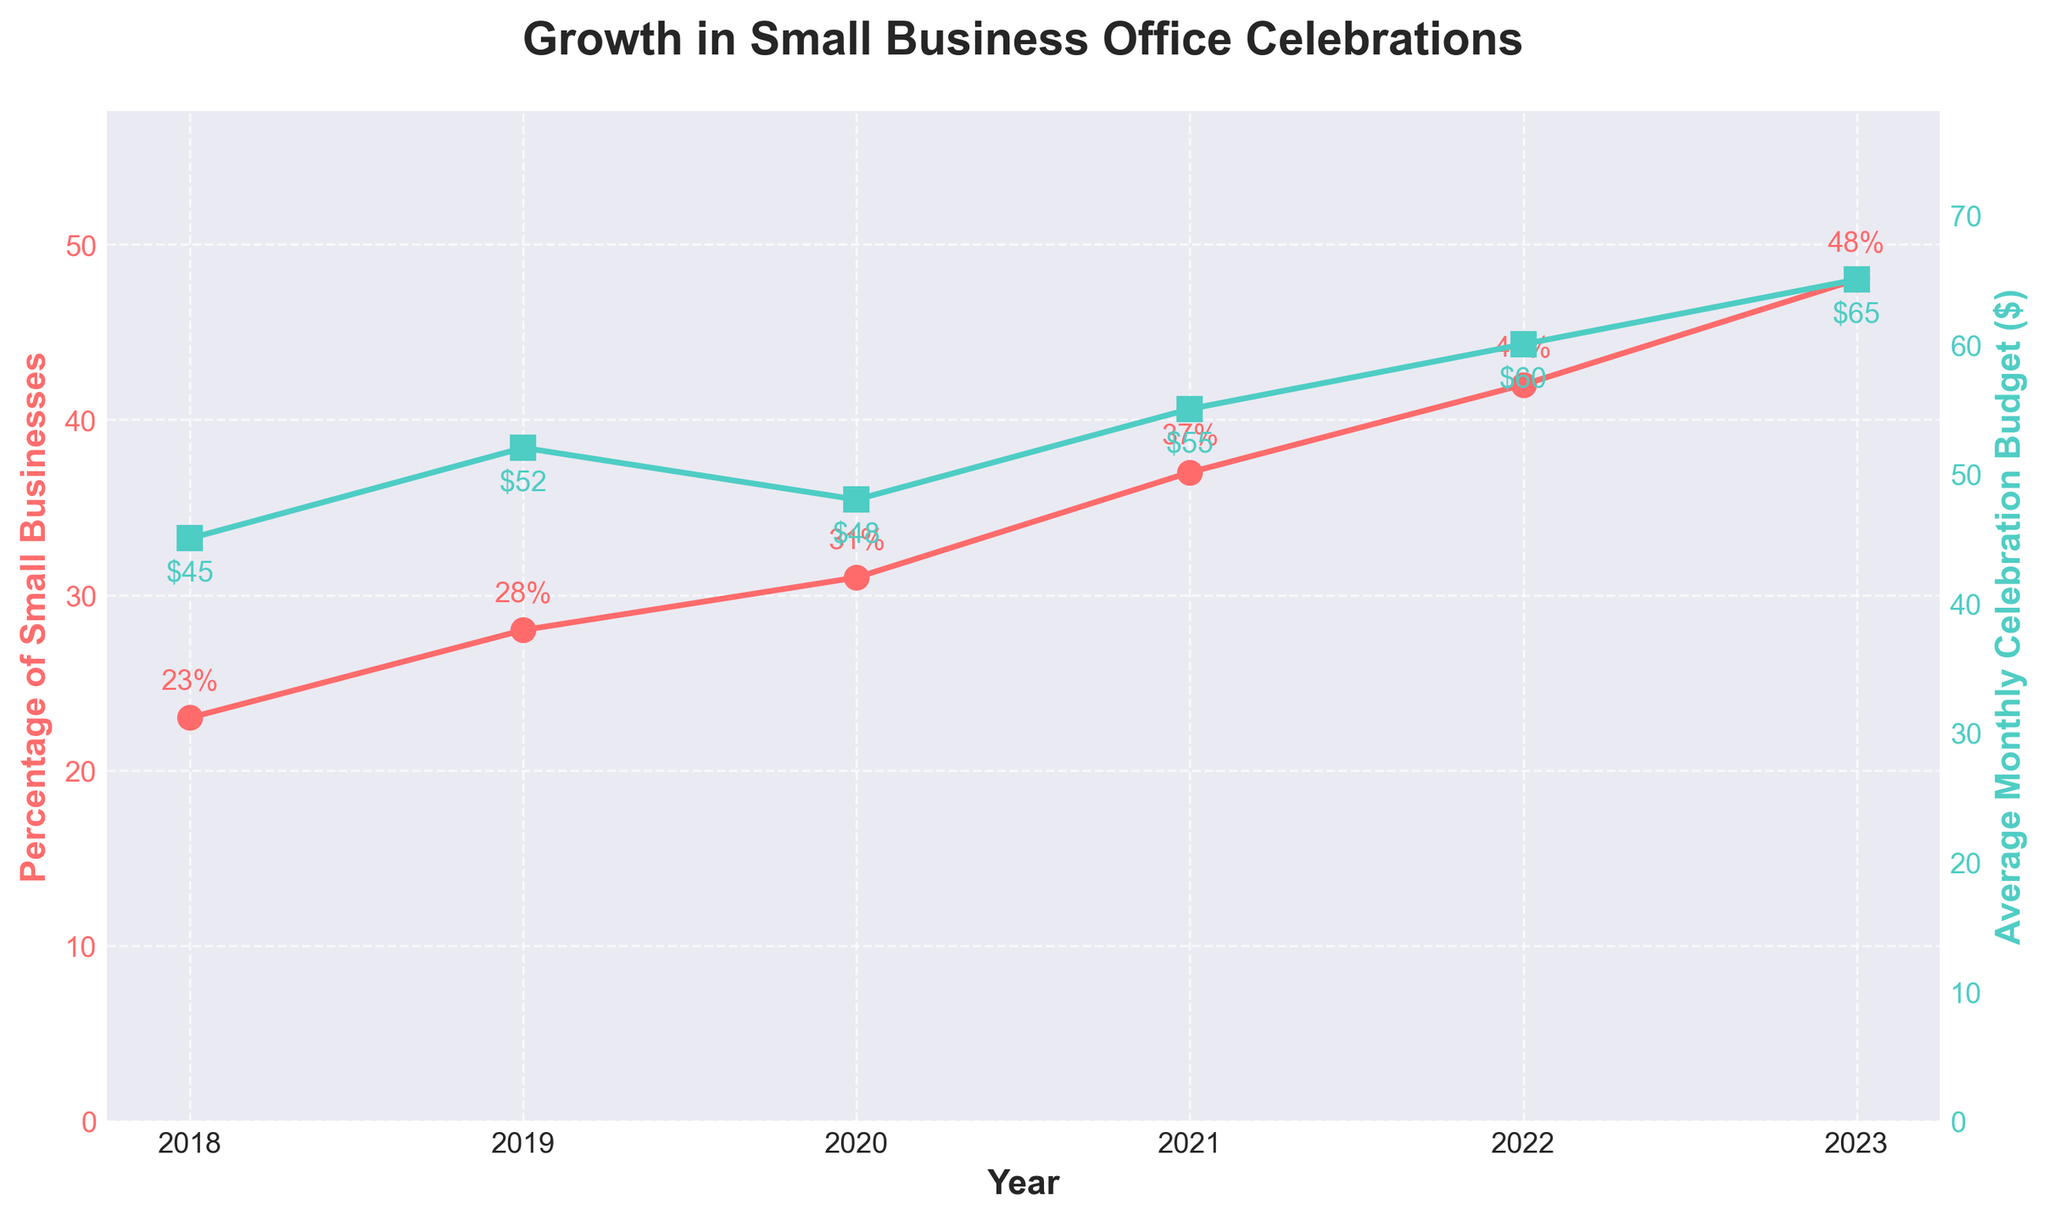What is the overall percentage increase in small businesses adopting office celebrations from 2018 to 2023? To find the percentage increase, subtract the percentage of small businesses in 2018 from the percentage in 2023, then divide by the 2018 value and multiply by 100. The calculation is ((48 - 23) / 23) * 100.
Answer: 108.7% How much did the average monthly celebration budget increase from 2020 to 2023? Subtract the average budget in 2020 from the budget in 2023. The calculation is 65 - 48.
Answer: $17 In which year did the percentage of small businesses adopting office celebrations exceed 30%? Look at the plotted percentages over the years and identify the first year in which the percentage exceeds 30%.
Answer: 2020 Between which two consecutive years did the average monthly celebration budget see the highest increase? Analyze the increments between consecutive years and determine which pair has the largest positive difference. The highest increase is from 2018 to 2019 with $7.
Answer: 2018-2019 Which series has higher values consistently throughout the years, percentage of small businesses or average monthly celebration budget? Compare the percentage of small businesses and the budget values across all years from the plotted lines.
Answer: Average monthly celebration budget How does the trend of the percentage of small businesses compare to the trend of the average monthly celebration budget over the years? Observe whether both trends are increasing and if any visible differences or similarities exist in their rates of increase across the years. Both trends are increasing, but the percentage of small businesses shows a smoother and more consistent upward trend compared to the budget which fluctuates.
Answer: Both increasing, with smoother trend in percentage growth What is the approximate year-over-year percentage increase for small businesses adopting office celebrations from 2022 to 2023? Subtract the percentage in 2022 from 2023, then divide by the percentage in 2022 and multiply by 100. The calculation is ((48 - 42) / 42) * 100.
Answer: 14.3% What was the percentage increase in the average celebration budget from 2019 to 2021? Subtract the budget in 2019 from 2021, then divide by the budget in 2019 and multiply by 100. The calculation is ((55 - 52) / 52) * 100.
Answer: 5.8% In which year did both the small businesses' adoption percentage and the budget increase, and what were their values in that year? Identify the years where both plotted lines show an increase and note their values. In 2019, the adoption percentage is 28% and the budget is $52.
Answer: 2019, 28%, $52 Which year had the smallest increase in the percentage of small businesses adopting celebrations compared to the previous year? Determine the year with the smallest positive variation between consecutive years. The smallest increase is from 2020 to 2021 with 6%.
Answer: 2020-2021 